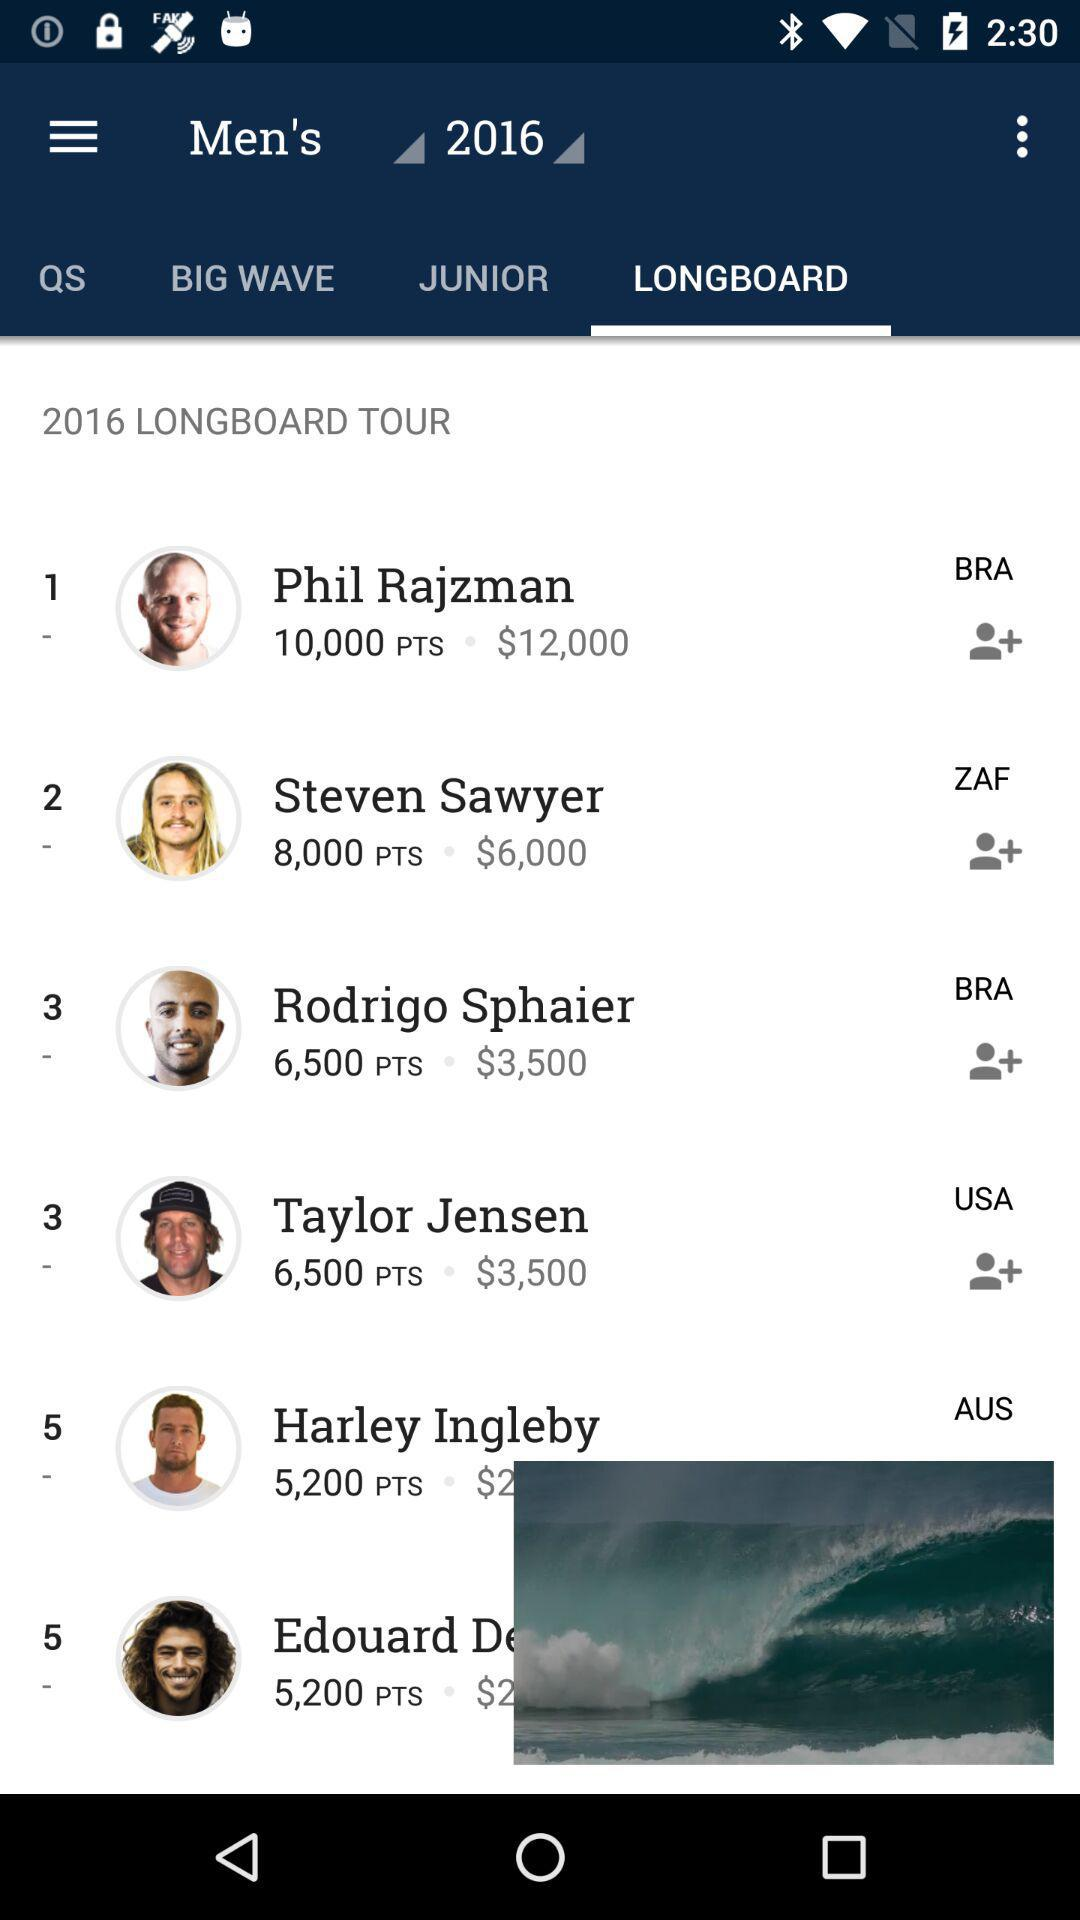Which option is selected? The selected option is "Longboard". 